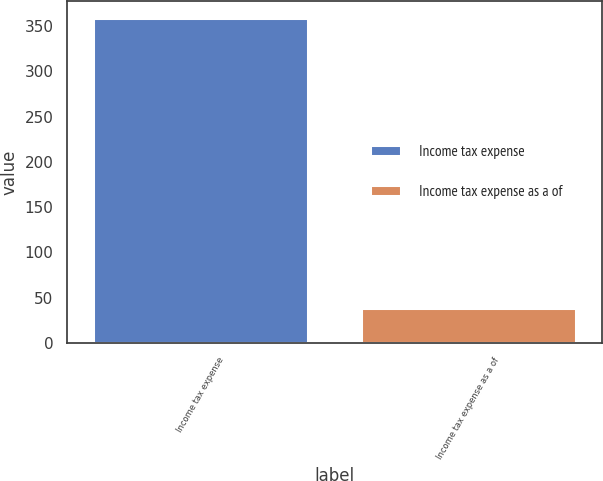Convert chart to OTSL. <chart><loc_0><loc_0><loc_500><loc_500><bar_chart><fcel>Income tax expense<fcel>Income tax expense as a of<nl><fcel>359.4<fcel>38.1<nl></chart> 